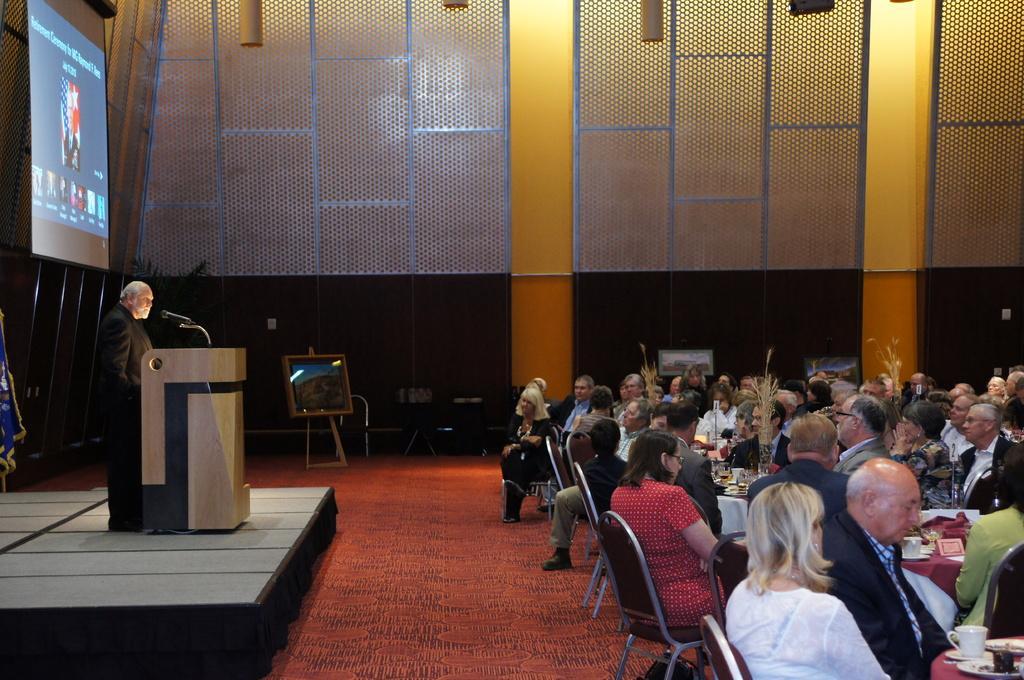Please provide a concise description of this image. Bottom right side of the image there are few tables on the tables there are some glasses, cups, saucers and plates. Surrounding the table there are few chairs, on the chairs there are few people sitting. Top right side of the image there is a wall. Bottom left side of the image a man is standing beside a podium. He is speaking on a microphone. Top left side of the image there is a screen. In the middle of the image there is a frame. bottom of the image there is a carpet. 